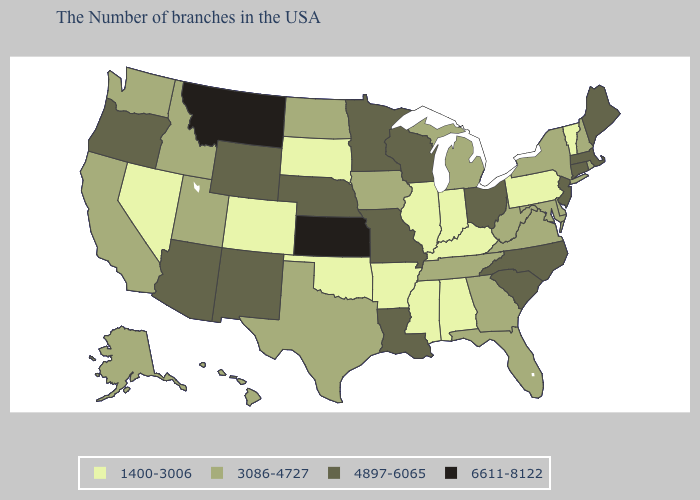Does New Mexico have the lowest value in the USA?
Concise answer only. No. Among the states that border Washington , which have the lowest value?
Short answer required. Idaho. What is the value of Alabama?
Answer briefly. 1400-3006. What is the value of Washington?
Be succinct. 3086-4727. What is the value of Tennessee?
Give a very brief answer. 3086-4727. Name the states that have a value in the range 3086-4727?
Write a very short answer. Rhode Island, New Hampshire, New York, Delaware, Maryland, Virginia, West Virginia, Florida, Georgia, Michigan, Tennessee, Iowa, Texas, North Dakota, Utah, Idaho, California, Washington, Alaska, Hawaii. Which states have the lowest value in the South?
Be succinct. Kentucky, Alabama, Mississippi, Arkansas, Oklahoma. What is the lowest value in states that border Ohio?
Quick response, please. 1400-3006. Does South Dakota have the same value as Colorado?
Short answer required. Yes. What is the value of Indiana?
Write a very short answer. 1400-3006. Among the states that border Missouri , which have the lowest value?
Write a very short answer. Kentucky, Illinois, Arkansas, Oklahoma. Is the legend a continuous bar?
Write a very short answer. No. Among the states that border Oregon , does Nevada have the lowest value?
Short answer required. Yes. Among the states that border New York , does Vermont have the highest value?
Answer briefly. No. What is the lowest value in the MidWest?
Answer briefly. 1400-3006. 